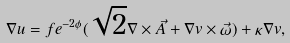Convert formula to latex. <formula><loc_0><loc_0><loc_500><loc_500>\nabla u = f e ^ { - 2 \phi } ( \sqrt { 2 } \nabla \times \vec { A } + \nabla v \times \vec { \omega } ) + \kappa \nabla v ,</formula> 